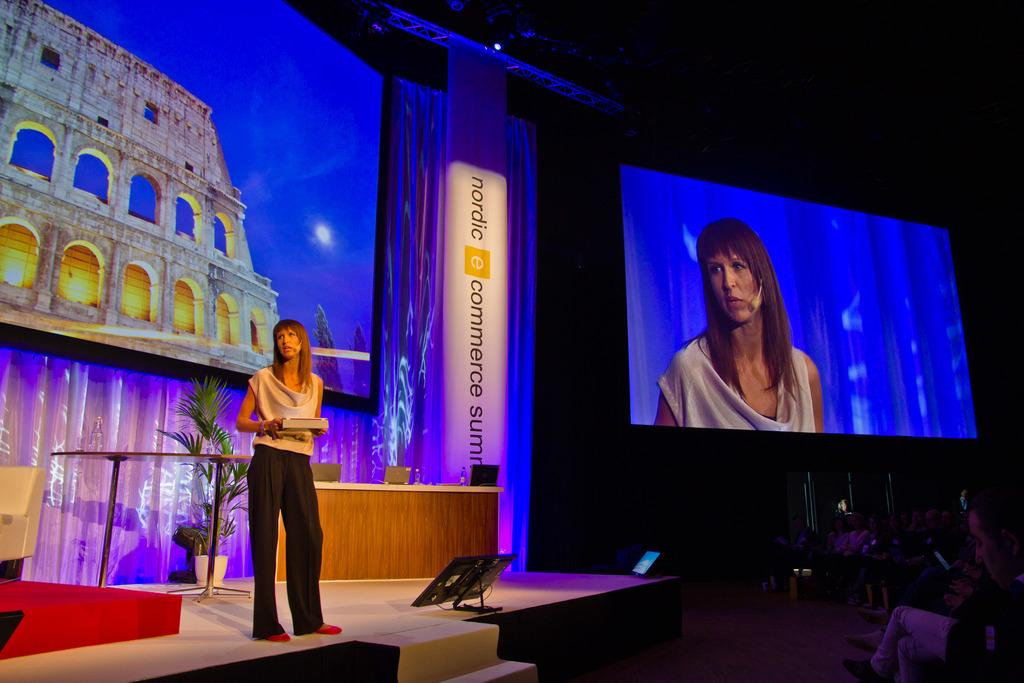What is the woman doing in the image? The woman is standing on the stage. What can be seen on the stage besides the woman? There are many items on the stage. What type of whistle can be heard during the woman's activity on the stage? There is no whistle present or audible in the image, as it is a still photograph. 